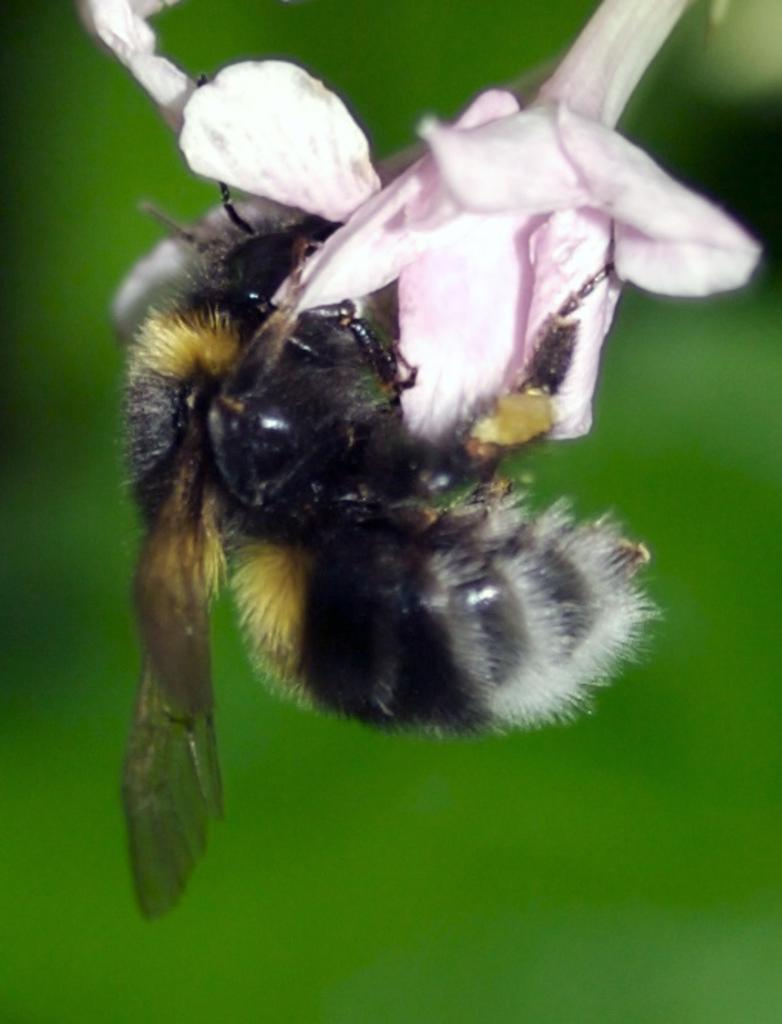What is present on the flower in the image? There is an insect on the flower in the image. What is the insect doing in the image? The insect is on the flower. Can you describe the background of the image? The background of the image is blurred. What type of glue is the insect using to stick the thumb to the sheep in the image? There is no glue, thumb, or sheep present in the image; it only features an insect on a flower with a blurred background. 